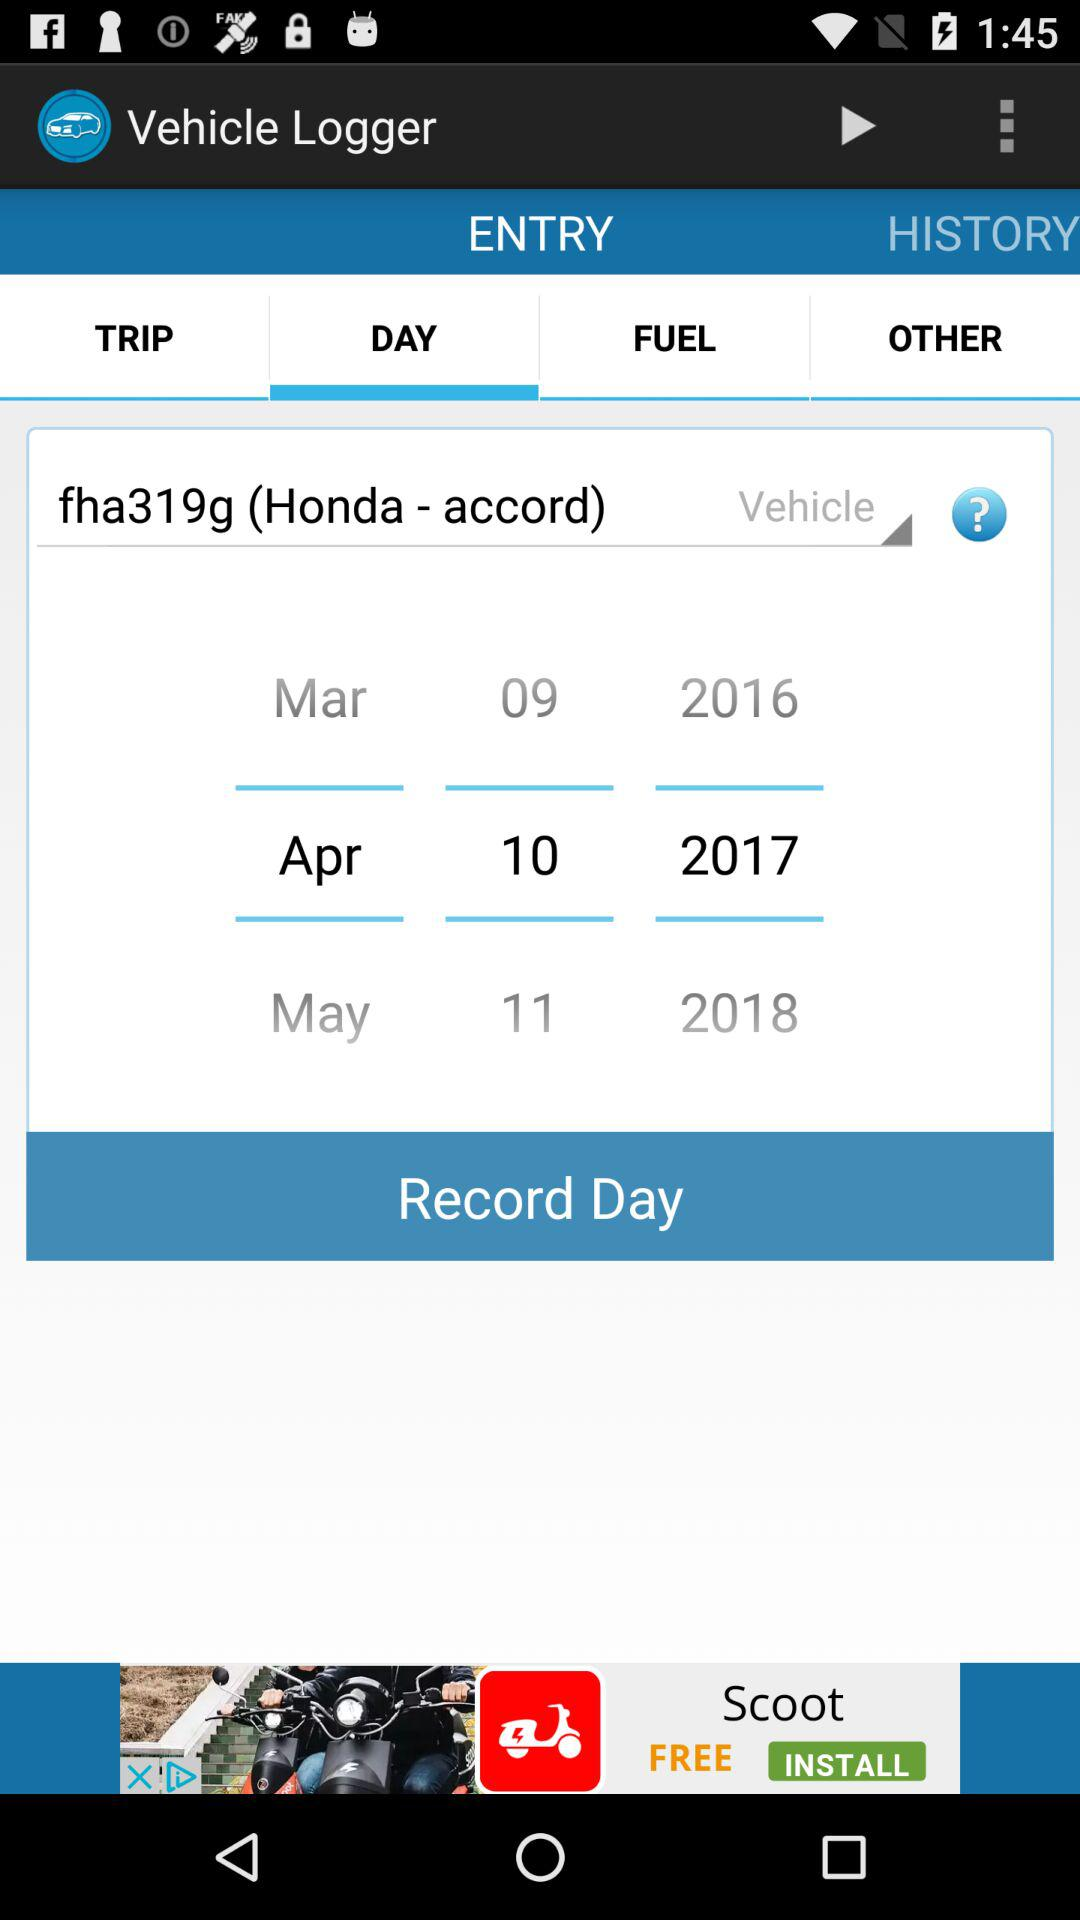What is the name of the vehicle? The name of the vehicle is "fha319g (Honda - accord)". 